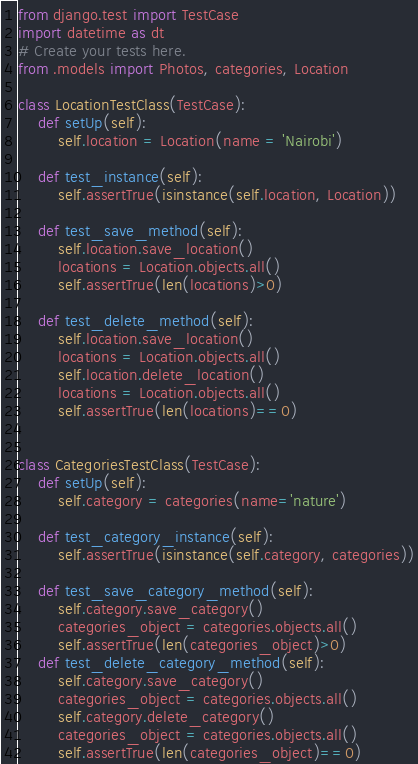<code> <loc_0><loc_0><loc_500><loc_500><_Python_>from django.test import TestCase
import datetime as dt
# Create your tests here.
from .models import Photos, categories, Location

class LocationTestClass(TestCase):
    def setUp(self):
        self.location = Location(name = 'Nairobi')

    def test_instance(self):
        self.assertTrue(isinstance(self.location, Location))

    def test_save_method(self):
        self.location.save_location()
        locations = Location.objects.all()
        self.assertTrue(len(locations)>0)

    def test_delete_method(self):
        self.location.save_location()
        locations = Location.objects.all()
        self.location.delete_location()
        locations = Location.objects.all()
        self.assertTrue(len(locations)==0)


class CategoriesTestClass(TestCase):
    def setUp(self):
        self.category = categories(name='nature')

    def test_category_instance(self):
        self.assertTrue(isinstance(self.category, categories))

    def test_save_category_method(self):
        self.category.save_category()
        categories_object = categories.objects.all()
        self.assertTrue(len(categories_object)>0)
    def test_delete_category_method(self):
        self.category.save_category()
        categories_object = categories.objects.all()
        self.category.delete_category()
        categories_object = categories.objects.all()
        self.assertTrue(len(categories_object)==0)
</code> 